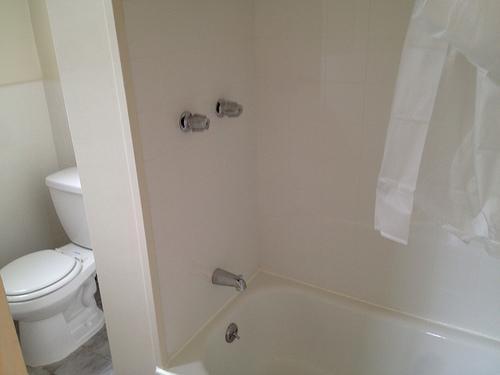How many toilets are in the room?
Give a very brief answer. 1. 